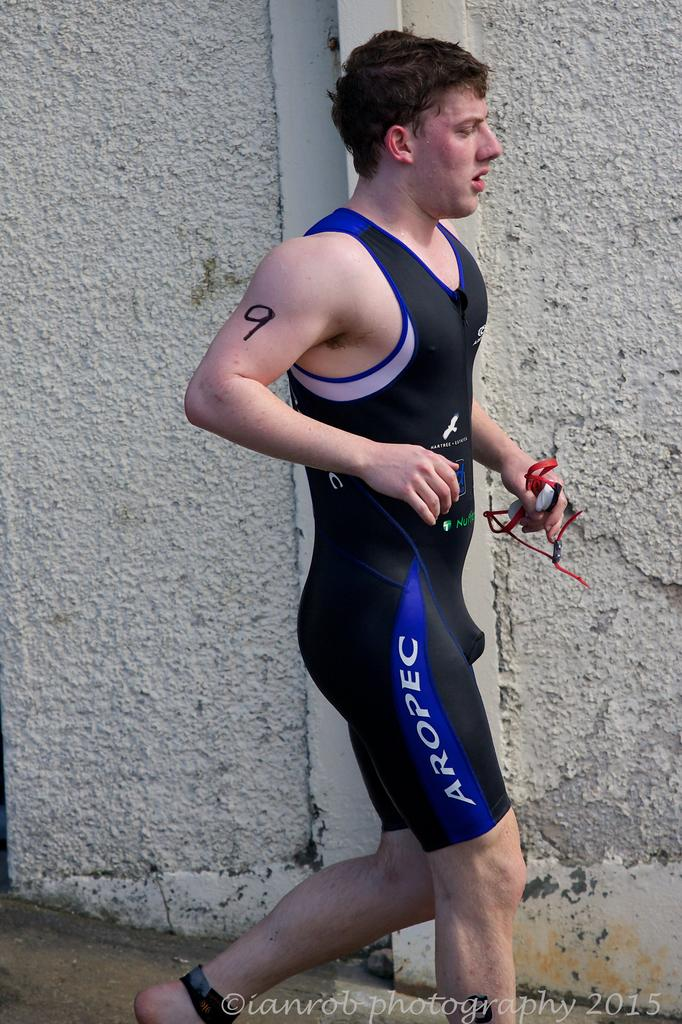Provide a one-sentence caption for the provided image. a man wearing AROPEC sportswear and a 9 on his arm.. 